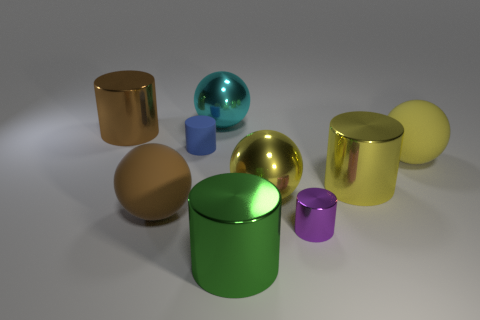Does the big brown rubber thing have the same shape as the blue thing that is to the left of the large yellow rubber ball? The big brown object and the blue object have different shapes. The brown object is cylindrical, while the blue object is shaped like a cube, therefore they do not share the same shape. 